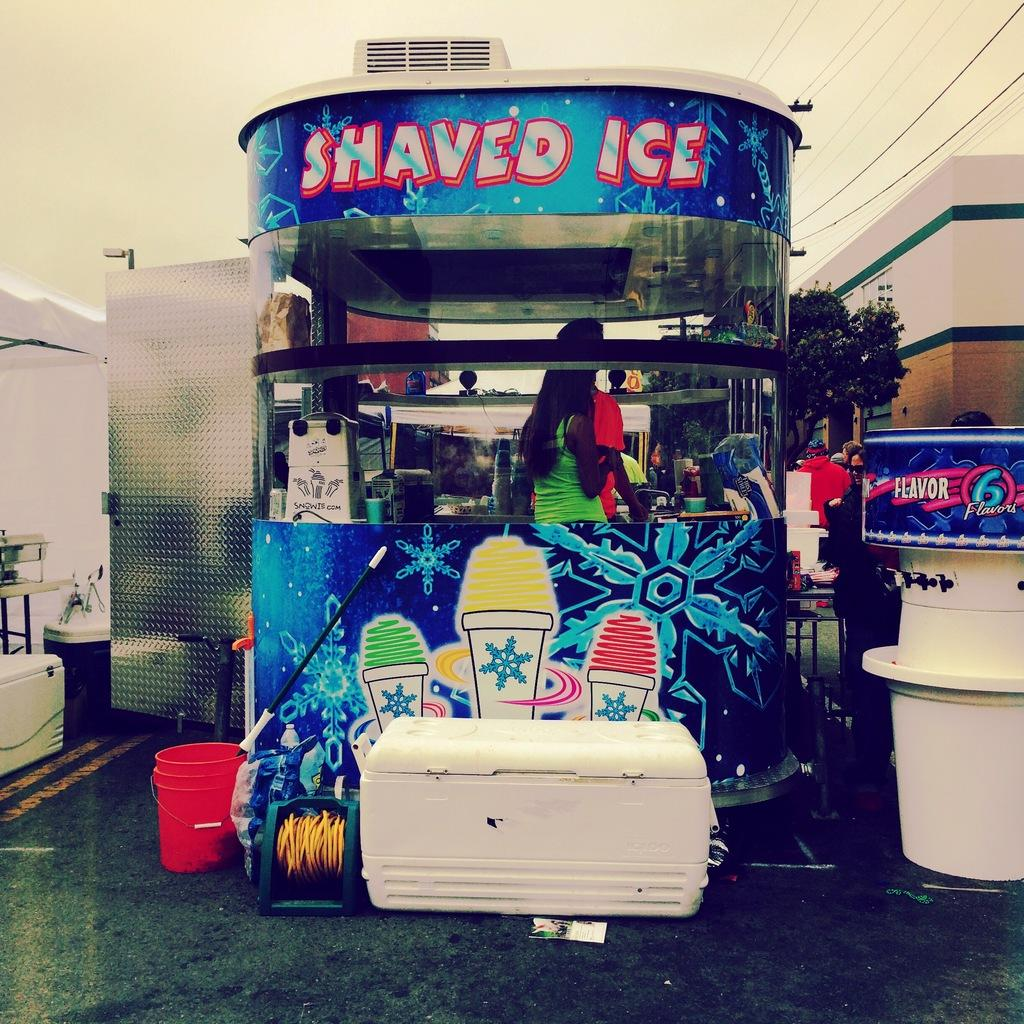What objects can be seen in the image? There is a box and a bucket in the image. What type of structure is present in the image? There is a stall in the image. How many people are inside the stall? There are two persons inside the stall. What can be seen in the background of the image? The background of the image includes people, trees, wires, and the sky. Can you see any veins in the apple that is being sold in the stall? There is no apple present in the image, and therefore no veins can be seen. 